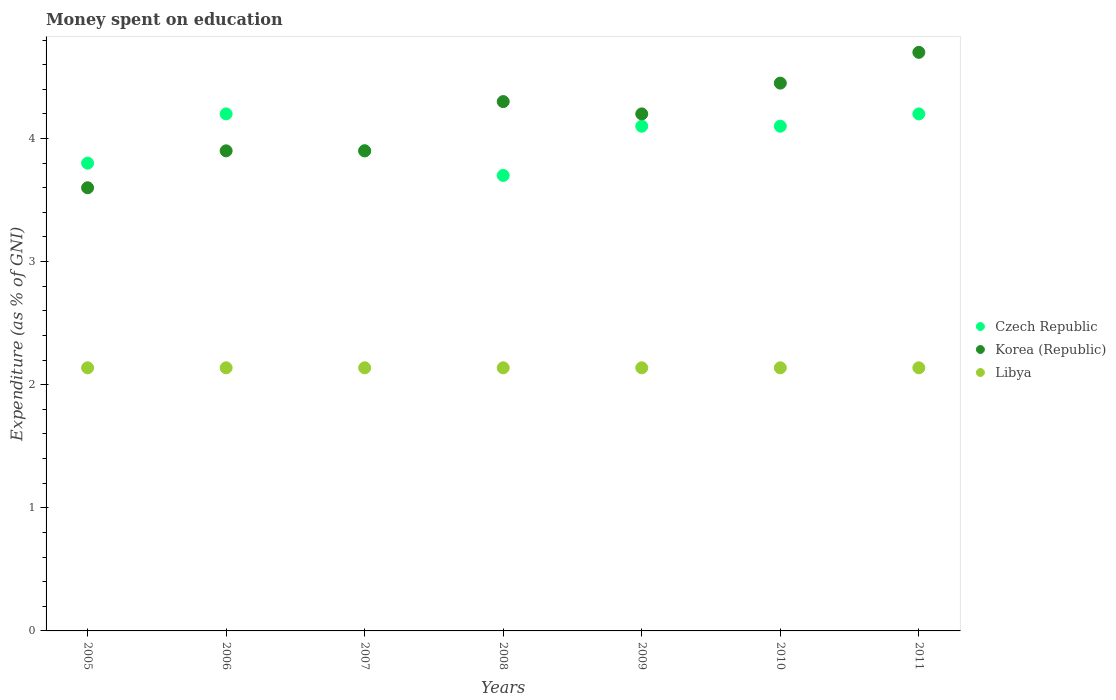Is the number of dotlines equal to the number of legend labels?
Make the answer very short. Yes. Across all years, what is the maximum amount of money spent on education in Libya?
Offer a very short reply. 2.14. Across all years, what is the minimum amount of money spent on education in Czech Republic?
Make the answer very short. 3.7. In which year was the amount of money spent on education in Libya minimum?
Ensure brevity in your answer.  2005. What is the total amount of money spent on education in Libya in the graph?
Give a very brief answer. 14.96. What is the difference between the amount of money spent on education in Korea (Republic) in 2007 and the amount of money spent on education in Czech Republic in 2010?
Give a very brief answer. -0.2. What is the average amount of money spent on education in Korea (Republic) per year?
Keep it short and to the point. 4.15. In the year 2011, what is the difference between the amount of money spent on education in Czech Republic and amount of money spent on education in Libya?
Keep it short and to the point. 2.06. In how many years, is the amount of money spent on education in Korea (Republic) greater than 0.6000000000000001 %?
Your answer should be very brief. 7. What is the ratio of the amount of money spent on education in Libya in 2005 to that in 2008?
Make the answer very short. 1. What is the difference between the highest and the lowest amount of money spent on education in Czech Republic?
Your response must be concise. 0.5. Is the sum of the amount of money spent on education in Libya in 2006 and 2007 greater than the maximum amount of money spent on education in Czech Republic across all years?
Ensure brevity in your answer.  Yes. Is the amount of money spent on education in Libya strictly greater than the amount of money spent on education in Korea (Republic) over the years?
Give a very brief answer. No. Is the amount of money spent on education in Czech Republic strictly less than the amount of money spent on education in Libya over the years?
Offer a very short reply. No. How many dotlines are there?
Your response must be concise. 3. Are the values on the major ticks of Y-axis written in scientific E-notation?
Your response must be concise. No. Where does the legend appear in the graph?
Provide a succinct answer. Center right. How many legend labels are there?
Provide a short and direct response. 3. What is the title of the graph?
Make the answer very short. Money spent on education. What is the label or title of the X-axis?
Give a very brief answer. Years. What is the label or title of the Y-axis?
Offer a terse response. Expenditure (as % of GNI). What is the Expenditure (as % of GNI) of Czech Republic in 2005?
Provide a succinct answer. 3.8. What is the Expenditure (as % of GNI) in Libya in 2005?
Your response must be concise. 2.14. What is the Expenditure (as % of GNI) of Czech Republic in 2006?
Provide a short and direct response. 4.2. What is the Expenditure (as % of GNI) of Korea (Republic) in 2006?
Make the answer very short. 3.9. What is the Expenditure (as % of GNI) of Libya in 2006?
Keep it short and to the point. 2.14. What is the Expenditure (as % of GNI) of Libya in 2007?
Offer a very short reply. 2.14. What is the Expenditure (as % of GNI) in Czech Republic in 2008?
Offer a very short reply. 3.7. What is the Expenditure (as % of GNI) in Korea (Republic) in 2008?
Your response must be concise. 4.3. What is the Expenditure (as % of GNI) of Libya in 2008?
Your response must be concise. 2.14. What is the Expenditure (as % of GNI) in Korea (Republic) in 2009?
Keep it short and to the point. 4.2. What is the Expenditure (as % of GNI) in Libya in 2009?
Your response must be concise. 2.14. What is the Expenditure (as % of GNI) in Czech Republic in 2010?
Offer a terse response. 4.1. What is the Expenditure (as % of GNI) in Korea (Republic) in 2010?
Your response must be concise. 4.45. What is the Expenditure (as % of GNI) of Libya in 2010?
Make the answer very short. 2.14. What is the Expenditure (as % of GNI) of Korea (Republic) in 2011?
Make the answer very short. 4.7. What is the Expenditure (as % of GNI) of Libya in 2011?
Offer a terse response. 2.14. Across all years, what is the maximum Expenditure (as % of GNI) of Libya?
Ensure brevity in your answer.  2.14. Across all years, what is the minimum Expenditure (as % of GNI) in Czech Republic?
Make the answer very short. 3.7. Across all years, what is the minimum Expenditure (as % of GNI) of Korea (Republic)?
Your response must be concise. 3.6. Across all years, what is the minimum Expenditure (as % of GNI) of Libya?
Your answer should be compact. 2.14. What is the total Expenditure (as % of GNI) in Korea (Republic) in the graph?
Make the answer very short. 29.05. What is the total Expenditure (as % of GNI) of Libya in the graph?
Ensure brevity in your answer.  14.96. What is the difference between the Expenditure (as % of GNI) in Czech Republic in 2005 and that in 2006?
Offer a very short reply. -0.4. What is the difference between the Expenditure (as % of GNI) of Korea (Republic) in 2005 and that in 2006?
Offer a very short reply. -0.3. What is the difference between the Expenditure (as % of GNI) of Czech Republic in 2005 and that in 2007?
Keep it short and to the point. -0.1. What is the difference between the Expenditure (as % of GNI) of Korea (Republic) in 2005 and that in 2007?
Offer a terse response. -0.3. What is the difference between the Expenditure (as % of GNI) in Libya in 2005 and that in 2007?
Offer a very short reply. 0. What is the difference between the Expenditure (as % of GNI) of Czech Republic in 2005 and that in 2008?
Your answer should be very brief. 0.1. What is the difference between the Expenditure (as % of GNI) of Korea (Republic) in 2005 and that in 2008?
Offer a very short reply. -0.7. What is the difference between the Expenditure (as % of GNI) of Libya in 2005 and that in 2008?
Your answer should be compact. 0. What is the difference between the Expenditure (as % of GNI) of Korea (Republic) in 2005 and that in 2010?
Your answer should be compact. -0.85. What is the difference between the Expenditure (as % of GNI) in Czech Republic in 2005 and that in 2011?
Your answer should be very brief. -0.4. What is the difference between the Expenditure (as % of GNI) in Korea (Republic) in 2005 and that in 2011?
Ensure brevity in your answer.  -1.1. What is the difference between the Expenditure (as % of GNI) in Czech Republic in 2006 and that in 2008?
Make the answer very short. 0.5. What is the difference between the Expenditure (as % of GNI) of Libya in 2006 and that in 2008?
Make the answer very short. 0. What is the difference between the Expenditure (as % of GNI) of Czech Republic in 2006 and that in 2009?
Provide a succinct answer. 0.1. What is the difference between the Expenditure (as % of GNI) of Libya in 2006 and that in 2009?
Your response must be concise. 0. What is the difference between the Expenditure (as % of GNI) of Korea (Republic) in 2006 and that in 2010?
Your answer should be compact. -0.55. What is the difference between the Expenditure (as % of GNI) of Libya in 2006 and that in 2010?
Your response must be concise. 0. What is the difference between the Expenditure (as % of GNI) of Libya in 2006 and that in 2011?
Offer a terse response. 0. What is the difference between the Expenditure (as % of GNI) in Libya in 2007 and that in 2008?
Your answer should be compact. 0. What is the difference between the Expenditure (as % of GNI) of Korea (Republic) in 2007 and that in 2009?
Provide a succinct answer. -0.3. What is the difference between the Expenditure (as % of GNI) in Libya in 2007 and that in 2009?
Your response must be concise. 0. What is the difference between the Expenditure (as % of GNI) of Korea (Republic) in 2007 and that in 2010?
Provide a short and direct response. -0.55. What is the difference between the Expenditure (as % of GNI) of Czech Republic in 2007 and that in 2011?
Ensure brevity in your answer.  -0.3. What is the difference between the Expenditure (as % of GNI) in Czech Republic in 2008 and that in 2010?
Keep it short and to the point. -0.4. What is the difference between the Expenditure (as % of GNI) of Czech Republic in 2008 and that in 2011?
Ensure brevity in your answer.  -0.5. What is the difference between the Expenditure (as % of GNI) of Korea (Republic) in 2008 and that in 2011?
Offer a very short reply. -0.4. What is the difference between the Expenditure (as % of GNI) in Libya in 2008 and that in 2011?
Give a very brief answer. 0. What is the difference between the Expenditure (as % of GNI) of Czech Republic in 2009 and that in 2010?
Provide a succinct answer. 0. What is the difference between the Expenditure (as % of GNI) in Korea (Republic) in 2009 and that in 2010?
Give a very brief answer. -0.25. What is the difference between the Expenditure (as % of GNI) in Libya in 2009 and that in 2011?
Your answer should be compact. 0. What is the difference between the Expenditure (as % of GNI) in Czech Republic in 2010 and that in 2011?
Offer a very short reply. -0.1. What is the difference between the Expenditure (as % of GNI) of Korea (Republic) in 2010 and that in 2011?
Give a very brief answer. -0.25. What is the difference between the Expenditure (as % of GNI) in Czech Republic in 2005 and the Expenditure (as % of GNI) in Korea (Republic) in 2006?
Your answer should be compact. -0.1. What is the difference between the Expenditure (as % of GNI) of Czech Republic in 2005 and the Expenditure (as % of GNI) of Libya in 2006?
Provide a succinct answer. 1.66. What is the difference between the Expenditure (as % of GNI) of Korea (Republic) in 2005 and the Expenditure (as % of GNI) of Libya in 2006?
Ensure brevity in your answer.  1.46. What is the difference between the Expenditure (as % of GNI) of Czech Republic in 2005 and the Expenditure (as % of GNI) of Korea (Republic) in 2007?
Keep it short and to the point. -0.1. What is the difference between the Expenditure (as % of GNI) in Czech Republic in 2005 and the Expenditure (as % of GNI) in Libya in 2007?
Provide a succinct answer. 1.66. What is the difference between the Expenditure (as % of GNI) of Korea (Republic) in 2005 and the Expenditure (as % of GNI) of Libya in 2007?
Offer a terse response. 1.46. What is the difference between the Expenditure (as % of GNI) in Czech Republic in 2005 and the Expenditure (as % of GNI) in Libya in 2008?
Provide a succinct answer. 1.66. What is the difference between the Expenditure (as % of GNI) of Korea (Republic) in 2005 and the Expenditure (as % of GNI) of Libya in 2008?
Make the answer very short. 1.46. What is the difference between the Expenditure (as % of GNI) of Czech Republic in 2005 and the Expenditure (as % of GNI) of Libya in 2009?
Provide a succinct answer. 1.66. What is the difference between the Expenditure (as % of GNI) of Korea (Republic) in 2005 and the Expenditure (as % of GNI) of Libya in 2009?
Your response must be concise. 1.46. What is the difference between the Expenditure (as % of GNI) in Czech Republic in 2005 and the Expenditure (as % of GNI) in Korea (Republic) in 2010?
Your answer should be compact. -0.65. What is the difference between the Expenditure (as % of GNI) in Czech Republic in 2005 and the Expenditure (as % of GNI) in Libya in 2010?
Your answer should be very brief. 1.66. What is the difference between the Expenditure (as % of GNI) of Korea (Republic) in 2005 and the Expenditure (as % of GNI) of Libya in 2010?
Provide a short and direct response. 1.46. What is the difference between the Expenditure (as % of GNI) of Czech Republic in 2005 and the Expenditure (as % of GNI) of Libya in 2011?
Provide a short and direct response. 1.66. What is the difference between the Expenditure (as % of GNI) in Korea (Republic) in 2005 and the Expenditure (as % of GNI) in Libya in 2011?
Your answer should be compact. 1.46. What is the difference between the Expenditure (as % of GNI) of Czech Republic in 2006 and the Expenditure (as % of GNI) of Korea (Republic) in 2007?
Your answer should be compact. 0.3. What is the difference between the Expenditure (as % of GNI) of Czech Republic in 2006 and the Expenditure (as % of GNI) of Libya in 2007?
Your answer should be very brief. 2.06. What is the difference between the Expenditure (as % of GNI) of Korea (Republic) in 2006 and the Expenditure (as % of GNI) of Libya in 2007?
Your answer should be compact. 1.76. What is the difference between the Expenditure (as % of GNI) of Czech Republic in 2006 and the Expenditure (as % of GNI) of Libya in 2008?
Offer a very short reply. 2.06. What is the difference between the Expenditure (as % of GNI) in Korea (Republic) in 2006 and the Expenditure (as % of GNI) in Libya in 2008?
Offer a very short reply. 1.76. What is the difference between the Expenditure (as % of GNI) in Czech Republic in 2006 and the Expenditure (as % of GNI) in Korea (Republic) in 2009?
Your response must be concise. 0. What is the difference between the Expenditure (as % of GNI) in Czech Republic in 2006 and the Expenditure (as % of GNI) in Libya in 2009?
Ensure brevity in your answer.  2.06. What is the difference between the Expenditure (as % of GNI) in Korea (Republic) in 2006 and the Expenditure (as % of GNI) in Libya in 2009?
Your answer should be very brief. 1.76. What is the difference between the Expenditure (as % of GNI) of Czech Republic in 2006 and the Expenditure (as % of GNI) of Korea (Republic) in 2010?
Your answer should be compact. -0.25. What is the difference between the Expenditure (as % of GNI) of Czech Republic in 2006 and the Expenditure (as % of GNI) of Libya in 2010?
Your response must be concise. 2.06. What is the difference between the Expenditure (as % of GNI) in Korea (Republic) in 2006 and the Expenditure (as % of GNI) in Libya in 2010?
Provide a succinct answer. 1.76. What is the difference between the Expenditure (as % of GNI) of Czech Republic in 2006 and the Expenditure (as % of GNI) of Korea (Republic) in 2011?
Your answer should be very brief. -0.5. What is the difference between the Expenditure (as % of GNI) of Czech Republic in 2006 and the Expenditure (as % of GNI) of Libya in 2011?
Your answer should be very brief. 2.06. What is the difference between the Expenditure (as % of GNI) in Korea (Republic) in 2006 and the Expenditure (as % of GNI) in Libya in 2011?
Provide a short and direct response. 1.76. What is the difference between the Expenditure (as % of GNI) of Czech Republic in 2007 and the Expenditure (as % of GNI) of Korea (Republic) in 2008?
Your response must be concise. -0.4. What is the difference between the Expenditure (as % of GNI) of Czech Republic in 2007 and the Expenditure (as % of GNI) of Libya in 2008?
Give a very brief answer. 1.76. What is the difference between the Expenditure (as % of GNI) in Korea (Republic) in 2007 and the Expenditure (as % of GNI) in Libya in 2008?
Ensure brevity in your answer.  1.76. What is the difference between the Expenditure (as % of GNI) of Czech Republic in 2007 and the Expenditure (as % of GNI) of Korea (Republic) in 2009?
Your answer should be very brief. -0.3. What is the difference between the Expenditure (as % of GNI) in Czech Republic in 2007 and the Expenditure (as % of GNI) in Libya in 2009?
Ensure brevity in your answer.  1.76. What is the difference between the Expenditure (as % of GNI) in Korea (Republic) in 2007 and the Expenditure (as % of GNI) in Libya in 2009?
Offer a terse response. 1.76. What is the difference between the Expenditure (as % of GNI) in Czech Republic in 2007 and the Expenditure (as % of GNI) in Korea (Republic) in 2010?
Ensure brevity in your answer.  -0.55. What is the difference between the Expenditure (as % of GNI) of Czech Republic in 2007 and the Expenditure (as % of GNI) of Libya in 2010?
Your response must be concise. 1.76. What is the difference between the Expenditure (as % of GNI) in Korea (Republic) in 2007 and the Expenditure (as % of GNI) in Libya in 2010?
Keep it short and to the point. 1.76. What is the difference between the Expenditure (as % of GNI) in Czech Republic in 2007 and the Expenditure (as % of GNI) in Korea (Republic) in 2011?
Keep it short and to the point. -0.8. What is the difference between the Expenditure (as % of GNI) of Czech Republic in 2007 and the Expenditure (as % of GNI) of Libya in 2011?
Your response must be concise. 1.76. What is the difference between the Expenditure (as % of GNI) of Korea (Republic) in 2007 and the Expenditure (as % of GNI) of Libya in 2011?
Ensure brevity in your answer.  1.76. What is the difference between the Expenditure (as % of GNI) of Czech Republic in 2008 and the Expenditure (as % of GNI) of Korea (Republic) in 2009?
Offer a terse response. -0.5. What is the difference between the Expenditure (as % of GNI) of Czech Republic in 2008 and the Expenditure (as % of GNI) of Libya in 2009?
Provide a short and direct response. 1.56. What is the difference between the Expenditure (as % of GNI) of Korea (Republic) in 2008 and the Expenditure (as % of GNI) of Libya in 2009?
Your answer should be compact. 2.16. What is the difference between the Expenditure (as % of GNI) in Czech Republic in 2008 and the Expenditure (as % of GNI) in Korea (Republic) in 2010?
Provide a succinct answer. -0.75. What is the difference between the Expenditure (as % of GNI) of Czech Republic in 2008 and the Expenditure (as % of GNI) of Libya in 2010?
Give a very brief answer. 1.56. What is the difference between the Expenditure (as % of GNI) in Korea (Republic) in 2008 and the Expenditure (as % of GNI) in Libya in 2010?
Provide a short and direct response. 2.16. What is the difference between the Expenditure (as % of GNI) of Czech Republic in 2008 and the Expenditure (as % of GNI) of Korea (Republic) in 2011?
Make the answer very short. -1. What is the difference between the Expenditure (as % of GNI) in Czech Republic in 2008 and the Expenditure (as % of GNI) in Libya in 2011?
Offer a very short reply. 1.56. What is the difference between the Expenditure (as % of GNI) of Korea (Republic) in 2008 and the Expenditure (as % of GNI) of Libya in 2011?
Give a very brief answer. 2.16. What is the difference between the Expenditure (as % of GNI) of Czech Republic in 2009 and the Expenditure (as % of GNI) of Korea (Republic) in 2010?
Provide a succinct answer. -0.35. What is the difference between the Expenditure (as % of GNI) of Czech Republic in 2009 and the Expenditure (as % of GNI) of Libya in 2010?
Ensure brevity in your answer.  1.96. What is the difference between the Expenditure (as % of GNI) in Korea (Republic) in 2009 and the Expenditure (as % of GNI) in Libya in 2010?
Your answer should be compact. 2.06. What is the difference between the Expenditure (as % of GNI) of Czech Republic in 2009 and the Expenditure (as % of GNI) of Korea (Republic) in 2011?
Your answer should be very brief. -0.6. What is the difference between the Expenditure (as % of GNI) in Czech Republic in 2009 and the Expenditure (as % of GNI) in Libya in 2011?
Your response must be concise. 1.96. What is the difference between the Expenditure (as % of GNI) of Korea (Republic) in 2009 and the Expenditure (as % of GNI) of Libya in 2011?
Ensure brevity in your answer.  2.06. What is the difference between the Expenditure (as % of GNI) of Czech Republic in 2010 and the Expenditure (as % of GNI) of Korea (Republic) in 2011?
Provide a short and direct response. -0.6. What is the difference between the Expenditure (as % of GNI) of Czech Republic in 2010 and the Expenditure (as % of GNI) of Libya in 2011?
Make the answer very short. 1.96. What is the difference between the Expenditure (as % of GNI) in Korea (Republic) in 2010 and the Expenditure (as % of GNI) in Libya in 2011?
Provide a succinct answer. 2.31. What is the average Expenditure (as % of GNI) of Czech Republic per year?
Provide a succinct answer. 4. What is the average Expenditure (as % of GNI) in Korea (Republic) per year?
Your response must be concise. 4.15. What is the average Expenditure (as % of GNI) of Libya per year?
Keep it short and to the point. 2.14. In the year 2005, what is the difference between the Expenditure (as % of GNI) in Czech Republic and Expenditure (as % of GNI) in Libya?
Keep it short and to the point. 1.66. In the year 2005, what is the difference between the Expenditure (as % of GNI) of Korea (Republic) and Expenditure (as % of GNI) of Libya?
Keep it short and to the point. 1.46. In the year 2006, what is the difference between the Expenditure (as % of GNI) in Czech Republic and Expenditure (as % of GNI) in Libya?
Your response must be concise. 2.06. In the year 2006, what is the difference between the Expenditure (as % of GNI) of Korea (Republic) and Expenditure (as % of GNI) of Libya?
Ensure brevity in your answer.  1.76. In the year 2007, what is the difference between the Expenditure (as % of GNI) of Czech Republic and Expenditure (as % of GNI) of Libya?
Provide a short and direct response. 1.76. In the year 2007, what is the difference between the Expenditure (as % of GNI) in Korea (Republic) and Expenditure (as % of GNI) in Libya?
Your response must be concise. 1.76. In the year 2008, what is the difference between the Expenditure (as % of GNI) of Czech Republic and Expenditure (as % of GNI) of Korea (Republic)?
Offer a very short reply. -0.6. In the year 2008, what is the difference between the Expenditure (as % of GNI) of Czech Republic and Expenditure (as % of GNI) of Libya?
Provide a short and direct response. 1.56. In the year 2008, what is the difference between the Expenditure (as % of GNI) of Korea (Republic) and Expenditure (as % of GNI) of Libya?
Give a very brief answer. 2.16. In the year 2009, what is the difference between the Expenditure (as % of GNI) in Czech Republic and Expenditure (as % of GNI) in Korea (Republic)?
Keep it short and to the point. -0.1. In the year 2009, what is the difference between the Expenditure (as % of GNI) in Czech Republic and Expenditure (as % of GNI) in Libya?
Your answer should be very brief. 1.96. In the year 2009, what is the difference between the Expenditure (as % of GNI) in Korea (Republic) and Expenditure (as % of GNI) in Libya?
Your answer should be very brief. 2.06. In the year 2010, what is the difference between the Expenditure (as % of GNI) in Czech Republic and Expenditure (as % of GNI) in Korea (Republic)?
Offer a terse response. -0.35. In the year 2010, what is the difference between the Expenditure (as % of GNI) in Czech Republic and Expenditure (as % of GNI) in Libya?
Ensure brevity in your answer.  1.96. In the year 2010, what is the difference between the Expenditure (as % of GNI) of Korea (Republic) and Expenditure (as % of GNI) of Libya?
Your response must be concise. 2.31. In the year 2011, what is the difference between the Expenditure (as % of GNI) of Czech Republic and Expenditure (as % of GNI) of Korea (Republic)?
Your answer should be very brief. -0.5. In the year 2011, what is the difference between the Expenditure (as % of GNI) in Czech Republic and Expenditure (as % of GNI) in Libya?
Your answer should be compact. 2.06. In the year 2011, what is the difference between the Expenditure (as % of GNI) of Korea (Republic) and Expenditure (as % of GNI) of Libya?
Provide a succinct answer. 2.56. What is the ratio of the Expenditure (as % of GNI) of Czech Republic in 2005 to that in 2006?
Your response must be concise. 0.9. What is the ratio of the Expenditure (as % of GNI) in Korea (Republic) in 2005 to that in 2006?
Make the answer very short. 0.92. What is the ratio of the Expenditure (as % of GNI) in Libya in 2005 to that in 2006?
Provide a succinct answer. 1. What is the ratio of the Expenditure (as % of GNI) of Czech Republic in 2005 to that in 2007?
Offer a terse response. 0.97. What is the ratio of the Expenditure (as % of GNI) of Korea (Republic) in 2005 to that in 2008?
Offer a very short reply. 0.84. What is the ratio of the Expenditure (as % of GNI) of Libya in 2005 to that in 2008?
Offer a terse response. 1. What is the ratio of the Expenditure (as % of GNI) in Czech Republic in 2005 to that in 2009?
Your answer should be compact. 0.93. What is the ratio of the Expenditure (as % of GNI) of Korea (Republic) in 2005 to that in 2009?
Provide a succinct answer. 0.86. What is the ratio of the Expenditure (as % of GNI) of Libya in 2005 to that in 2009?
Keep it short and to the point. 1. What is the ratio of the Expenditure (as % of GNI) in Czech Republic in 2005 to that in 2010?
Make the answer very short. 0.93. What is the ratio of the Expenditure (as % of GNI) in Korea (Republic) in 2005 to that in 2010?
Your answer should be very brief. 0.81. What is the ratio of the Expenditure (as % of GNI) in Czech Republic in 2005 to that in 2011?
Give a very brief answer. 0.9. What is the ratio of the Expenditure (as % of GNI) of Korea (Republic) in 2005 to that in 2011?
Ensure brevity in your answer.  0.77. What is the ratio of the Expenditure (as % of GNI) in Korea (Republic) in 2006 to that in 2007?
Your response must be concise. 1. What is the ratio of the Expenditure (as % of GNI) in Libya in 2006 to that in 2007?
Give a very brief answer. 1. What is the ratio of the Expenditure (as % of GNI) of Czech Republic in 2006 to that in 2008?
Your answer should be compact. 1.14. What is the ratio of the Expenditure (as % of GNI) of Korea (Republic) in 2006 to that in 2008?
Offer a terse response. 0.91. What is the ratio of the Expenditure (as % of GNI) of Libya in 2006 to that in 2008?
Keep it short and to the point. 1. What is the ratio of the Expenditure (as % of GNI) of Czech Republic in 2006 to that in 2009?
Offer a very short reply. 1.02. What is the ratio of the Expenditure (as % of GNI) in Libya in 2006 to that in 2009?
Your response must be concise. 1. What is the ratio of the Expenditure (as % of GNI) of Czech Republic in 2006 to that in 2010?
Make the answer very short. 1.02. What is the ratio of the Expenditure (as % of GNI) in Korea (Republic) in 2006 to that in 2010?
Ensure brevity in your answer.  0.88. What is the ratio of the Expenditure (as % of GNI) in Libya in 2006 to that in 2010?
Your response must be concise. 1. What is the ratio of the Expenditure (as % of GNI) in Czech Republic in 2006 to that in 2011?
Your answer should be compact. 1. What is the ratio of the Expenditure (as % of GNI) of Korea (Republic) in 2006 to that in 2011?
Offer a terse response. 0.83. What is the ratio of the Expenditure (as % of GNI) in Czech Republic in 2007 to that in 2008?
Make the answer very short. 1.05. What is the ratio of the Expenditure (as % of GNI) in Korea (Republic) in 2007 to that in 2008?
Your answer should be compact. 0.91. What is the ratio of the Expenditure (as % of GNI) of Libya in 2007 to that in 2008?
Provide a succinct answer. 1. What is the ratio of the Expenditure (as % of GNI) in Czech Republic in 2007 to that in 2009?
Your response must be concise. 0.95. What is the ratio of the Expenditure (as % of GNI) of Czech Republic in 2007 to that in 2010?
Give a very brief answer. 0.95. What is the ratio of the Expenditure (as % of GNI) of Korea (Republic) in 2007 to that in 2010?
Ensure brevity in your answer.  0.88. What is the ratio of the Expenditure (as % of GNI) in Libya in 2007 to that in 2010?
Make the answer very short. 1. What is the ratio of the Expenditure (as % of GNI) of Czech Republic in 2007 to that in 2011?
Make the answer very short. 0.93. What is the ratio of the Expenditure (as % of GNI) of Korea (Republic) in 2007 to that in 2011?
Your response must be concise. 0.83. What is the ratio of the Expenditure (as % of GNI) of Libya in 2007 to that in 2011?
Your response must be concise. 1. What is the ratio of the Expenditure (as % of GNI) of Czech Republic in 2008 to that in 2009?
Offer a very short reply. 0.9. What is the ratio of the Expenditure (as % of GNI) in Korea (Republic) in 2008 to that in 2009?
Your answer should be very brief. 1.02. What is the ratio of the Expenditure (as % of GNI) of Libya in 2008 to that in 2009?
Your answer should be very brief. 1. What is the ratio of the Expenditure (as % of GNI) of Czech Republic in 2008 to that in 2010?
Offer a very short reply. 0.9. What is the ratio of the Expenditure (as % of GNI) in Korea (Republic) in 2008 to that in 2010?
Keep it short and to the point. 0.97. What is the ratio of the Expenditure (as % of GNI) of Libya in 2008 to that in 2010?
Keep it short and to the point. 1. What is the ratio of the Expenditure (as % of GNI) in Czech Republic in 2008 to that in 2011?
Offer a terse response. 0.88. What is the ratio of the Expenditure (as % of GNI) of Korea (Republic) in 2008 to that in 2011?
Ensure brevity in your answer.  0.91. What is the ratio of the Expenditure (as % of GNI) of Korea (Republic) in 2009 to that in 2010?
Your answer should be compact. 0.94. What is the ratio of the Expenditure (as % of GNI) of Czech Republic in 2009 to that in 2011?
Offer a terse response. 0.98. What is the ratio of the Expenditure (as % of GNI) in Korea (Republic) in 2009 to that in 2011?
Offer a very short reply. 0.89. What is the ratio of the Expenditure (as % of GNI) in Libya in 2009 to that in 2011?
Keep it short and to the point. 1. What is the ratio of the Expenditure (as % of GNI) in Czech Republic in 2010 to that in 2011?
Your answer should be compact. 0.98. What is the ratio of the Expenditure (as % of GNI) of Korea (Republic) in 2010 to that in 2011?
Your answer should be compact. 0.95. What is the ratio of the Expenditure (as % of GNI) of Libya in 2010 to that in 2011?
Ensure brevity in your answer.  1. What is the difference between the highest and the second highest Expenditure (as % of GNI) in Czech Republic?
Offer a terse response. 0. What is the difference between the highest and the lowest Expenditure (as % of GNI) in Libya?
Keep it short and to the point. 0. 